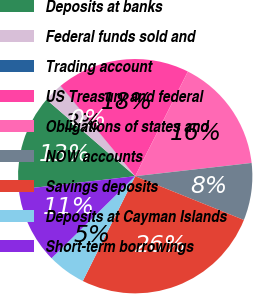Convert chart. <chart><loc_0><loc_0><loc_500><loc_500><pie_chart><fcel>Deposits at banks<fcel>Federal funds sold and<fcel>Trading account<fcel>US Treasury and federal<fcel>Obligations of states and<fcel>NOW accounts<fcel>Savings deposits<fcel>Deposits at Cayman Islands<fcel>Short-term borrowings<nl><fcel>13.15%<fcel>2.65%<fcel>0.03%<fcel>18.4%<fcel>15.78%<fcel>7.9%<fcel>26.28%<fcel>5.28%<fcel>10.53%<nl></chart> 